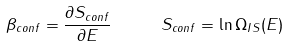Convert formula to latex. <formula><loc_0><loc_0><loc_500><loc_500>\beta _ { c o n f } = \frac { \partial S _ { c o n f } } { \partial E } \quad \ S _ { c o n f } = \ln \Omega _ { I S } ( E )</formula> 